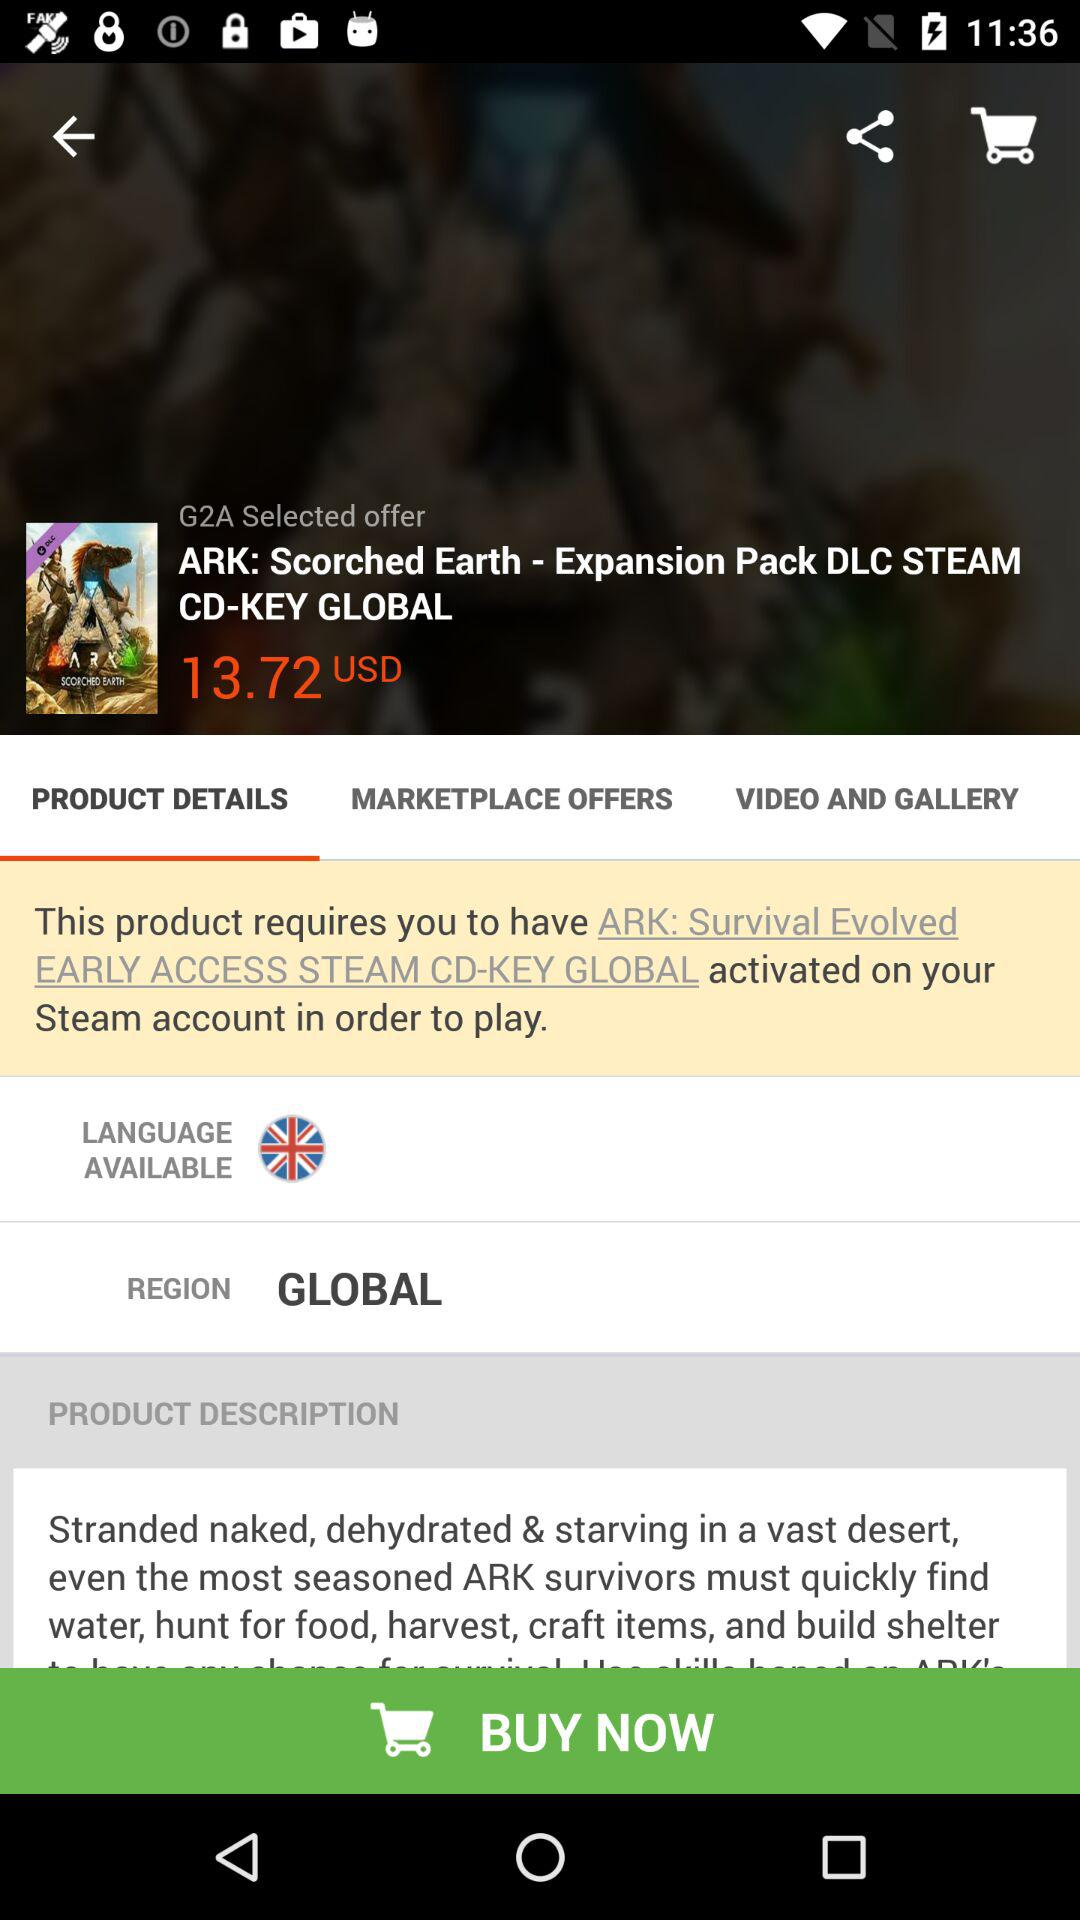What is the price? The price is 13.72 USD. 